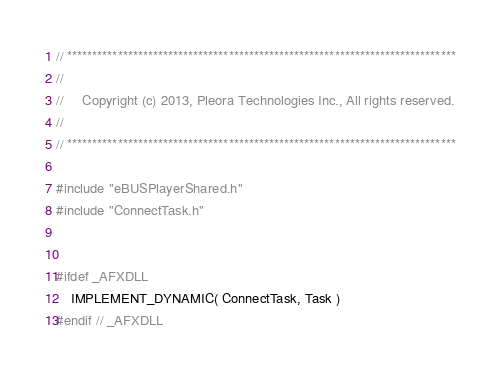<code> <loc_0><loc_0><loc_500><loc_500><_C++_>// *****************************************************************************
//
//     Copyright (c) 2013, Pleora Technologies Inc., All rights reserved.
//
// *****************************************************************************

#include "eBUSPlayerShared.h"
#include "ConnectTask.h"


#ifdef _AFXDLL
    IMPLEMENT_DYNAMIC( ConnectTask, Task )
#endif // _AFXDLL


</code> 